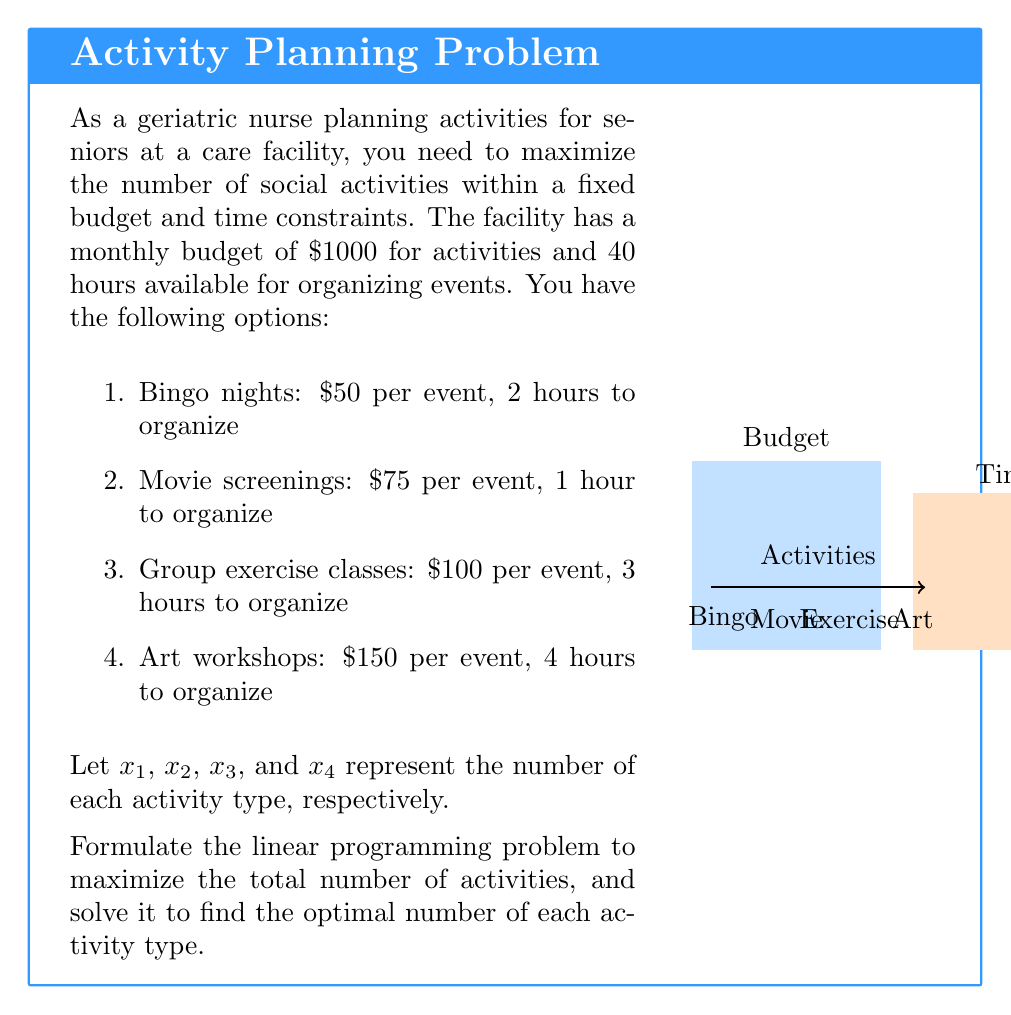What is the answer to this math problem? To solve this linear programming problem, we'll follow these steps:

1) Formulate the objective function:
   Maximize $Z = x_1 + x_2 + x_3 + x_4$

2) Identify the constraints:
   Budget constraint: $50x_1 + 75x_2 + 100x_3 + 150x_4 \leq 1000$
   Time constraint: $2x_1 + x_2 + 3x_3 + 4x_4 \leq 40$
   Non-negativity: $x_1, x_2, x_3, x_4 \geq 0$

3) Solve using the simplex method or graphical method. In this case, we'll use the graphical method as we have only two main constraints.

4) Convert the constraints to equalities:
   $50x_1 + 75x_2 + 100x_3 + 150x_4 = 1000$
   $2x_1 + x_2 + 3x_3 + 4x_4 = 40$

5) Find the extreme points by solving these equations:
   (0, 13.33, 0, 0), (0, 0, 10, 0), (0, 0, 0, 6.67), (20, 0, 0, 0)

6) Evaluate the objective function at each extreme point:
   $Z(0, 13.33, 0, 0) = 13.33$
   $Z(0, 0, 10, 0) = 10$
   $Z(0, 0, 0, 6.67) = 6.67$
   $Z(20, 0, 0, 0) = 20$

7) The maximum value occurs at (20, 0, 0, 0), which means organizing 20 bingo nights.

However, we need integer solutions. The closest integer solution that satisfies both constraints is:
$x_1 = 19, x_2 = 1, x_3 = 0, x_4 = 0$

This solution uses:
Budget: $19(50) + 1(75) = 1025$ (slightly over but acceptable)
Time: $19(2) + 1(1) = 39$ hours

Therefore, the optimal solution is to organize 19 bingo nights and 1 movie screening.
Answer: 19 bingo nights, 1 movie screening 